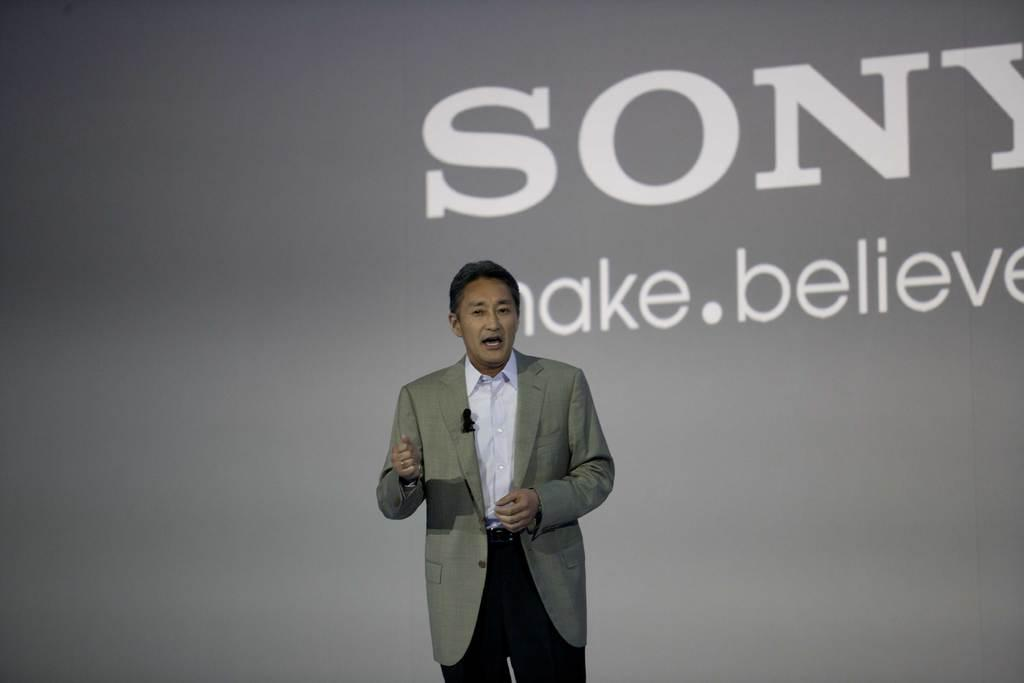What is the person in the image doing? The person in the image is speaking. What can be seen in the background of the image? There is a wall with writing on it in the background of the image. What type of animal is depicted on the wall in the image? There is no animal depicted on the wall in the image; it only has writing on it. 